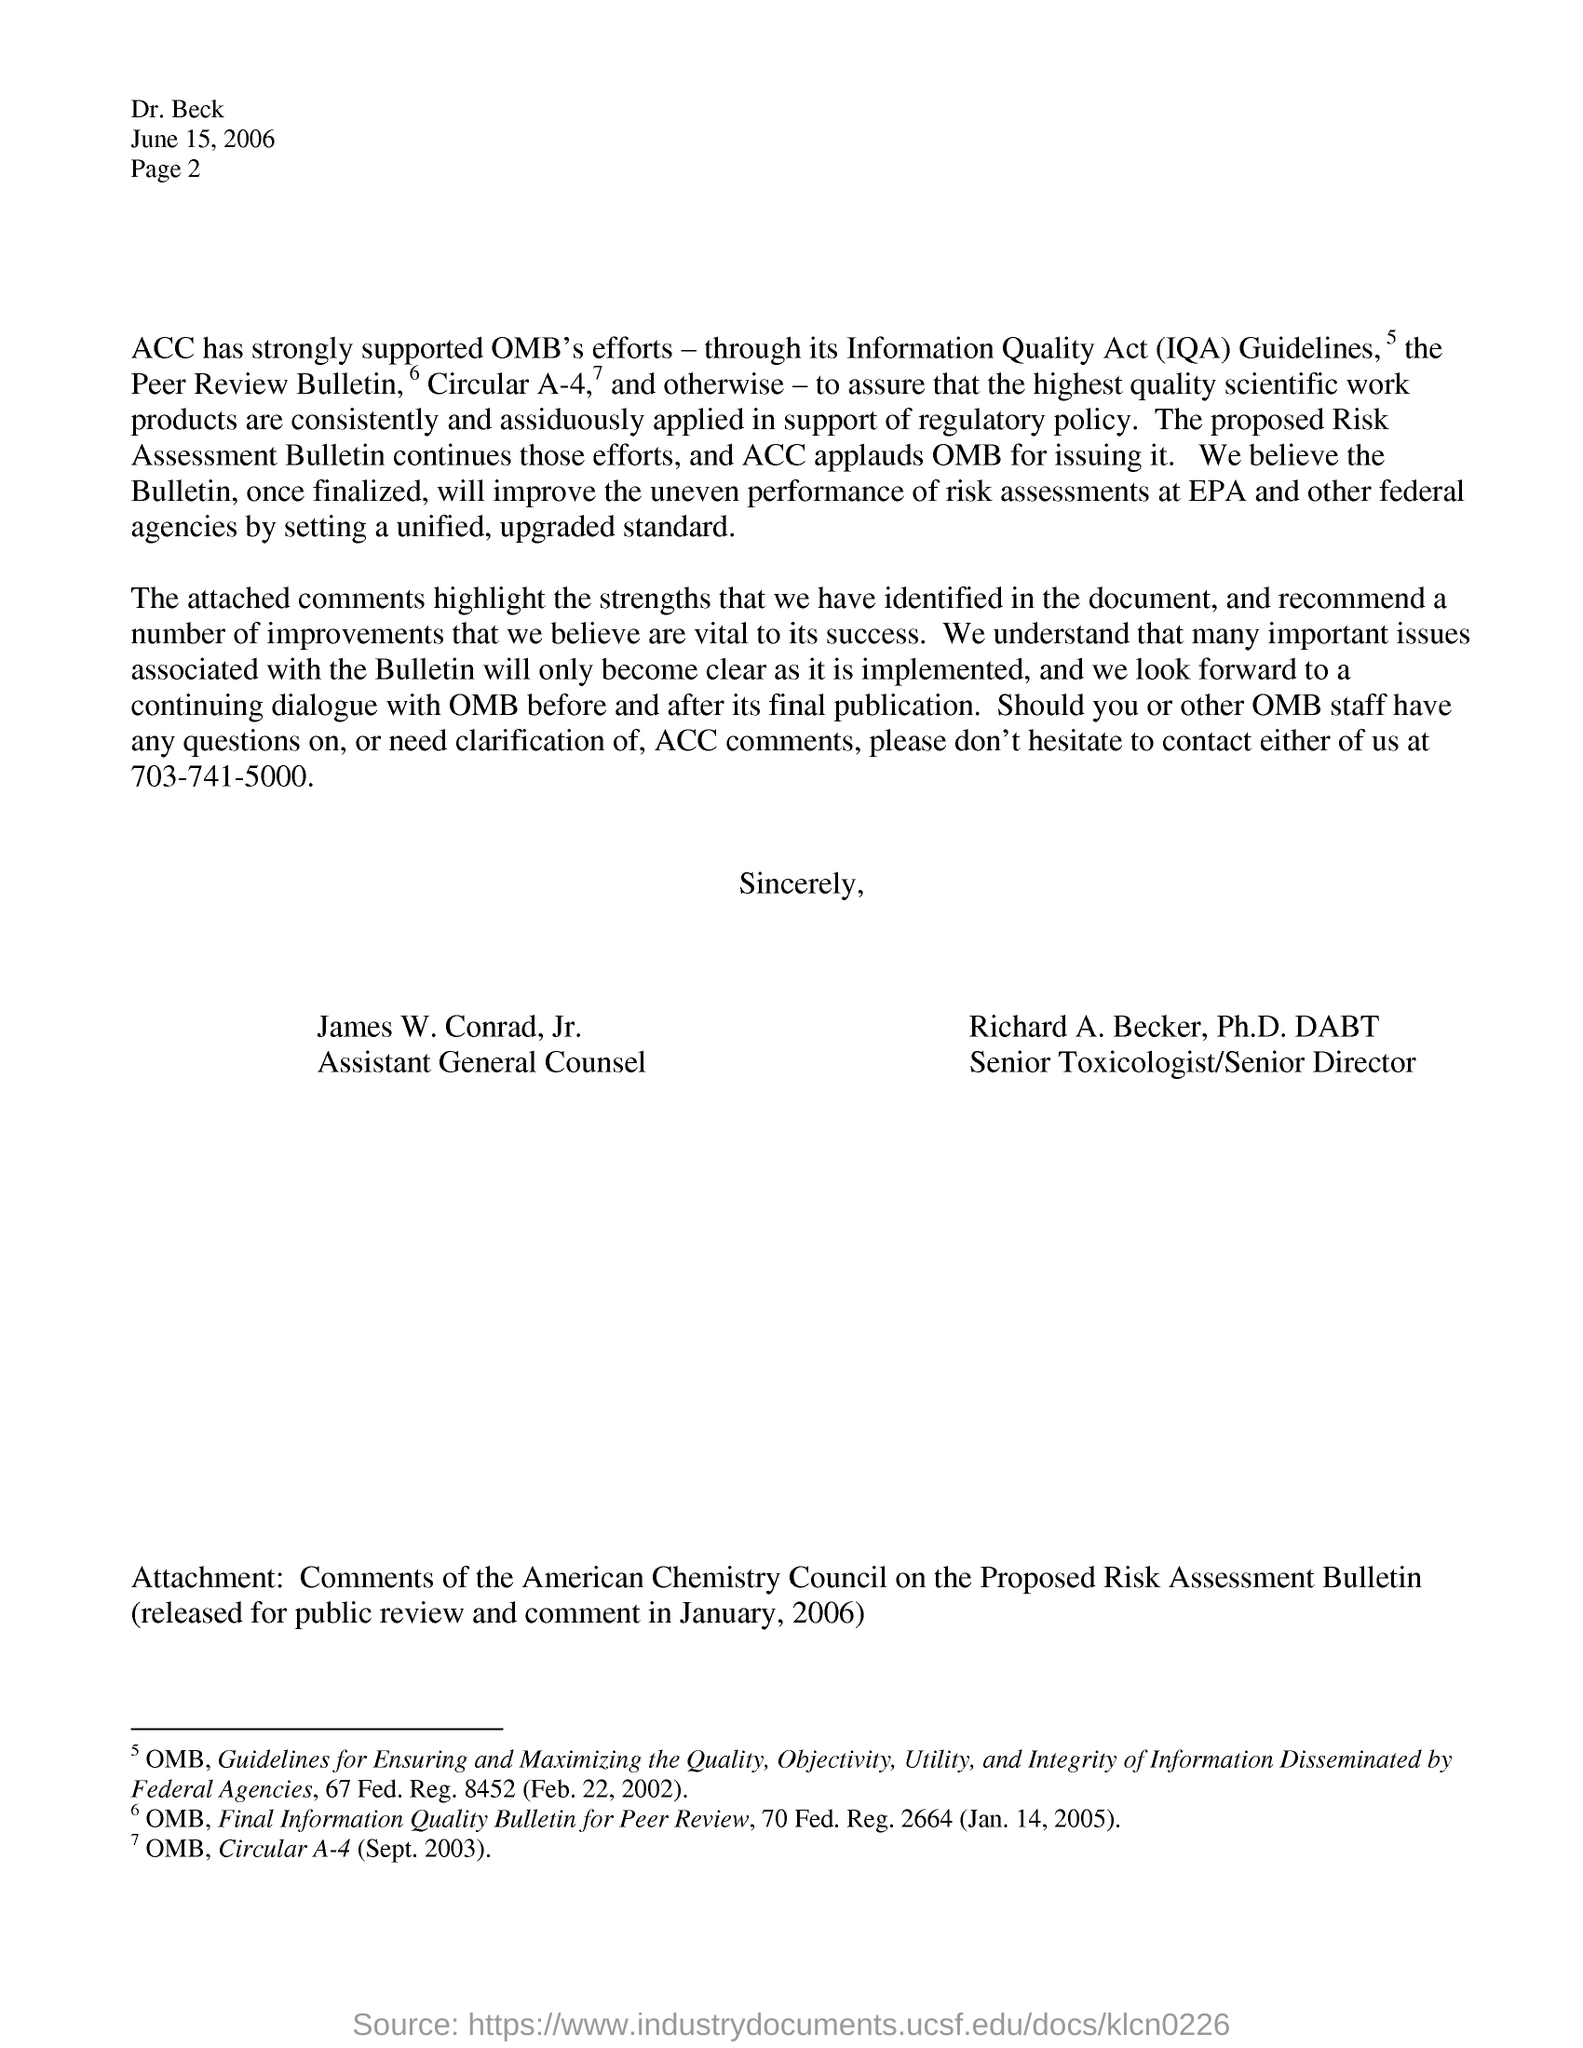Point out several critical features in this image. The date, JUNE 15, 2006, is located on the right side top of the letter. James W. Conrad, Jr. is the Assistant General Counsel. Richard A. Becker, Ph.D., DABT, is the senior toxicologist/senior director. The Information Quality Act, also known as Section 514 of the Treasury and General Government Appropriations Act for Fiscal Year 2001, is a United States federal law that requires federal agencies to improve the quality of the information they disseminate to the public. This includes ensuring that the information is accurate, reliable, and trustworthy, and that it is presented in a clear and easily understandable manner. The law was enacted in order to promote transparency and accountability in government and to ensure that the public has access to accurate and reliable information when making decisions that affect their lives. The organization has championed the Office of Management and Budget's initiatives through adherence to the Information Quality Act (IQA) guidelines, as evidenced by its acronym, ACC. 